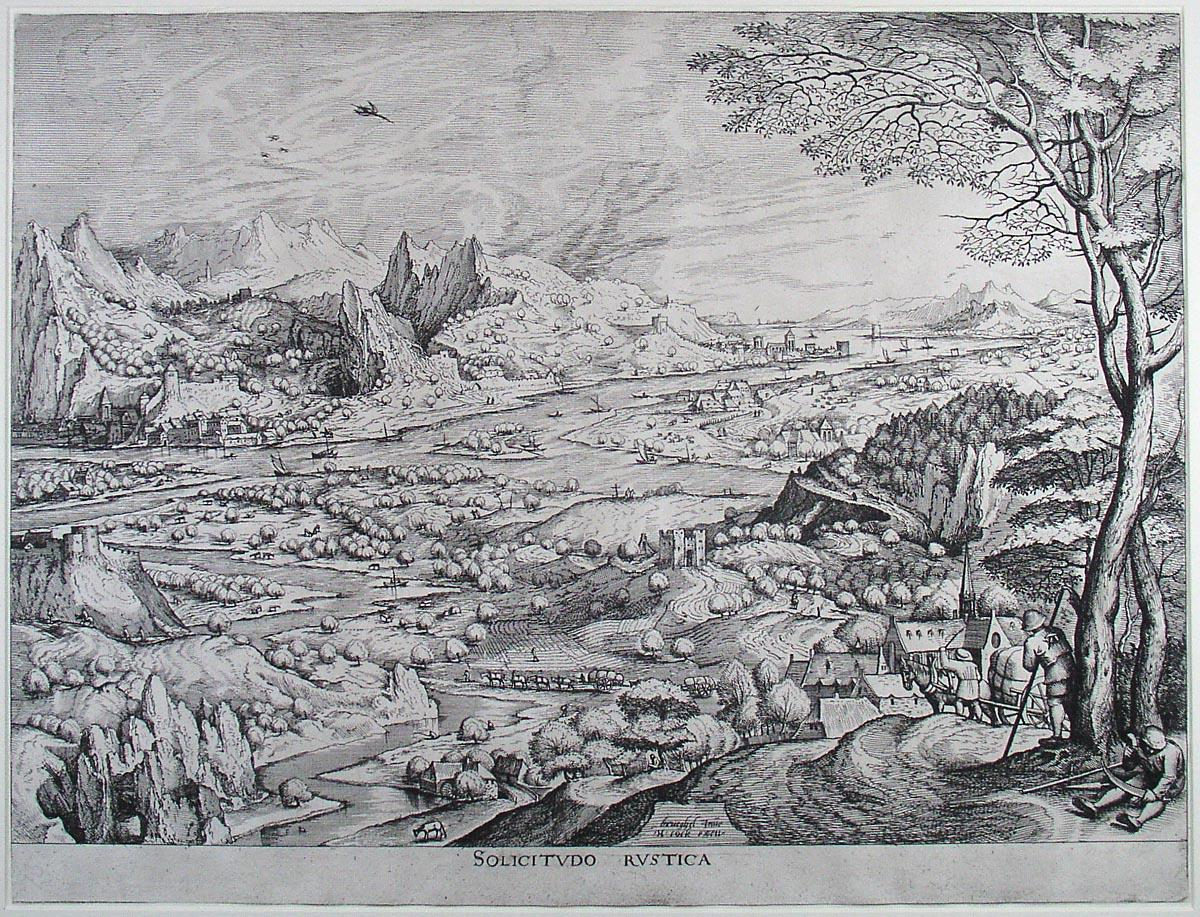Explain the visual content of the image in great detail. This image is a finely detailed black and white etching from the Renaissance period, revealing a sprawling rural landscape from a bird's eye view. The central feature is a meandering river that gracefully cuts through the scene, bordered by lush trees, expansive fields, and various buildings. The foreground shows people engaged in agricultural activities, indicative of rural life. Small hamlets and structures are scattered across the landscape, providing a glimpse into the architecture of the time. The background is dominated by towering mountains, giving a sense of depth and grandeur to the etching. Noteworthy is the inclusion of the text 'SOLICITVDO RUSTICA' at the bottom of the scene, which likely serves as the title or a descriptive phrase highlighting the rural tranquility of the countryside. The intricate detailing and realistic portrayal reflect the Renaissance focus on naturalism and the beauty of the natural world. 